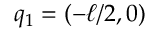Convert formula to latex. <formula><loc_0><loc_0><loc_500><loc_500>q _ { 1 } = ( - \ell / 2 , 0 )</formula> 